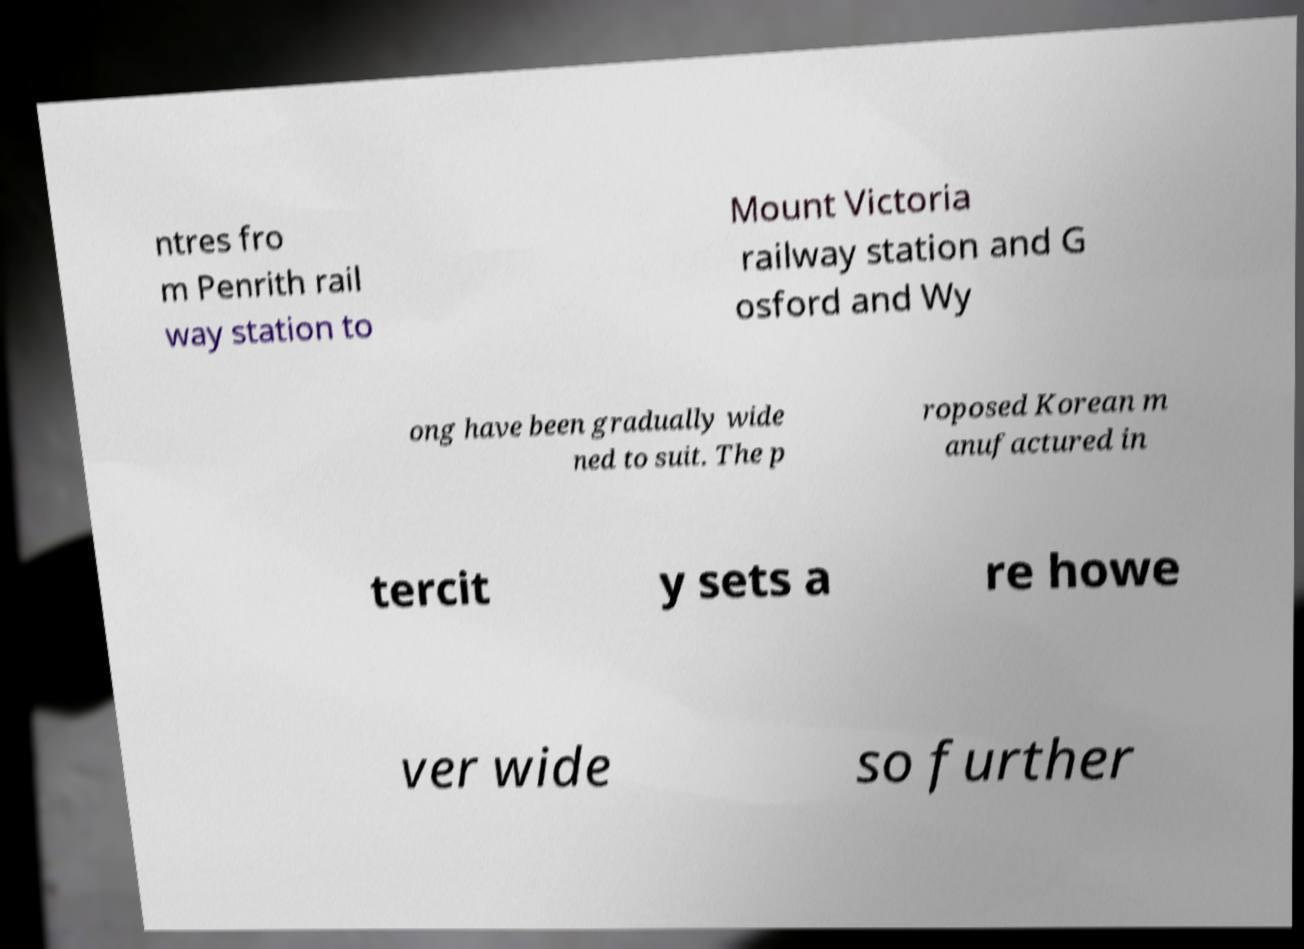Could you assist in decoding the text presented in this image and type it out clearly? ntres fro m Penrith rail way station to Mount Victoria railway station and G osford and Wy ong have been gradually wide ned to suit. The p roposed Korean m anufactured in tercit y sets a re howe ver wide so further 